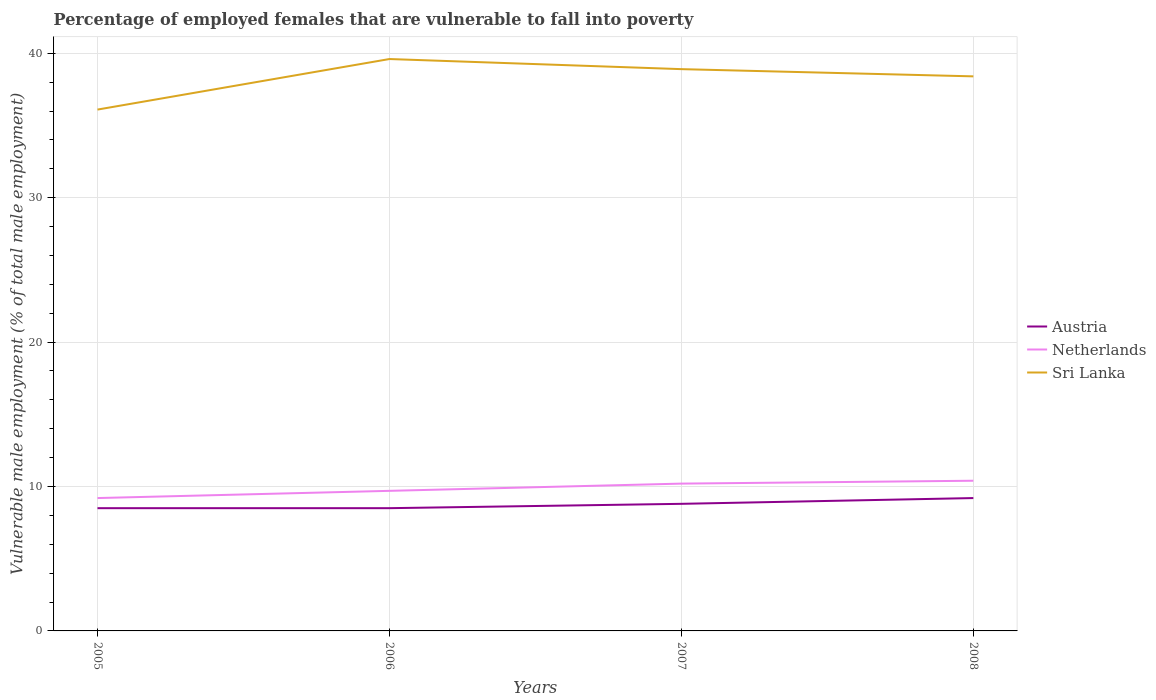How many different coloured lines are there?
Your response must be concise. 3. Does the line corresponding to Netherlands intersect with the line corresponding to Austria?
Give a very brief answer. No. In which year was the percentage of employed females who are vulnerable to fall into poverty in Netherlands maximum?
Offer a very short reply. 2005. What is the total percentage of employed females who are vulnerable to fall into poverty in Austria in the graph?
Your answer should be compact. -0.4. What is the difference between the highest and the second highest percentage of employed females who are vulnerable to fall into poverty in Netherlands?
Your answer should be very brief. 1.2. What is the difference between the highest and the lowest percentage of employed females who are vulnerable to fall into poverty in Austria?
Offer a terse response. 2. Is the percentage of employed females who are vulnerable to fall into poverty in Sri Lanka strictly greater than the percentage of employed females who are vulnerable to fall into poverty in Austria over the years?
Your answer should be compact. No. How many lines are there?
Provide a succinct answer. 3. How many years are there in the graph?
Your answer should be very brief. 4. Where does the legend appear in the graph?
Your answer should be very brief. Center right. How many legend labels are there?
Your response must be concise. 3. How are the legend labels stacked?
Your answer should be very brief. Vertical. What is the title of the graph?
Provide a short and direct response. Percentage of employed females that are vulnerable to fall into poverty. What is the label or title of the Y-axis?
Make the answer very short. Vulnerable male employment (% of total male employment). What is the Vulnerable male employment (% of total male employment) in Austria in 2005?
Ensure brevity in your answer.  8.5. What is the Vulnerable male employment (% of total male employment) of Netherlands in 2005?
Offer a very short reply. 9.2. What is the Vulnerable male employment (% of total male employment) in Sri Lanka in 2005?
Provide a succinct answer. 36.1. What is the Vulnerable male employment (% of total male employment) of Netherlands in 2006?
Keep it short and to the point. 9.7. What is the Vulnerable male employment (% of total male employment) in Sri Lanka in 2006?
Provide a succinct answer. 39.6. What is the Vulnerable male employment (% of total male employment) in Austria in 2007?
Provide a short and direct response. 8.8. What is the Vulnerable male employment (% of total male employment) in Netherlands in 2007?
Your answer should be very brief. 10.2. What is the Vulnerable male employment (% of total male employment) in Sri Lanka in 2007?
Keep it short and to the point. 38.9. What is the Vulnerable male employment (% of total male employment) of Austria in 2008?
Ensure brevity in your answer.  9.2. What is the Vulnerable male employment (% of total male employment) in Netherlands in 2008?
Your answer should be compact. 10.4. What is the Vulnerable male employment (% of total male employment) of Sri Lanka in 2008?
Give a very brief answer. 38.4. Across all years, what is the maximum Vulnerable male employment (% of total male employment) of Austria?
Offer a very short reply. 9.2. Across all years, what is the maximum Vulnerable male employment (% of total male employment) in Netherlands?
Ensure brevity in your answer.  10.4. Across all years, what is the maximum Vulnerable male employment (% of total male employment) of Sri Lanka?
Keep it short and to the point. 39.6. Across all years, what is the minimum Vulnerable male employment (% of total male employment) of Austria?
Your answer should be very brief. 8.5. Across all years, what is the minimum Vulnerable male employment (% of total male employment) in Netherlands?
Keep it short and to the point. 9.2. Across all years, what is the minimum Vulnerable male employment (% of total male employment) in Sri Lanka?
Provide a succinct answer. 36.1. What is the total Vulnerable male employment (% of total male employment) in Austria in the graph?
Offer a very short reply. 35. What is the total Vulnerable male employment (% of total male employment) in Netherlands in the graph?
Provide a succinct answer. 39.5. What is the total Vulnerable male employment (% of total male employment) in Sri Lanka in the graph?
Ensure brevity in your answer.  153. What is the difference between the Vulnerable male employment (% of total male employment) of Austria in 2005 and that in 2006?
Provide a short and direct response. 0. What is the difference between the Vulnerable male employment (% of total male employment) in Netherlands in 2005 and that in 2007?
Keep it short and to the point. -1. What is the difference between the Vulnerable male employment (% of total male employment) of Austria in 2006 and that in 2007?
Offer a very short reply. -0.3. What is the difference between the Vulnerable male employment (% of total male employment) in Austria in 2006 and that in 2008?
Your answer should be compact. -0.7. What is the difference between the Vulnerable male employment (% of total male employment) in Netherlands in 2006 and that in 2008?
Provide a succinct answer. -0.7. What is the difference between the Vulnerable male employment (% of total male employment) in Sri Lanka in 2006 and that in 2008?
Offer a very short reply. 1.2. What is the difference between the Vulnerable male employment (% of total male employment) of Netherlands in 2007 and that in 2008?
Provide a succinct answer. -0.2. What is the difference between the Vulnerable male employment (% of total male employment) of Austria in 2005 and the Vulnerable male employment (% of total male employment) of Netherlands in 2006?
Your response must be concise. -1.2. What is the difference between the Vulnerable male employment (% of total male employment) of Austria in 2005 and the Vulnerable male employment (% of total male employment) of Sri Lanka in 2006?
Provide a short and direct response. -31.1. What is the difference between the Vulnerable male employment (% of total male employment) in Netherlands in 2005 and the Vulnerable male employment (% of total male employment) in Sri Lanka in 2006?
Your answer should be very brief. -30.4. What is the difference between the Vulnerable male employment (% of total male employment) in Austria in 2005 and the Vulnerable male employment (% of total male employment) in Sri Lanka in 2007?
Make the answer very short. -30.4. What is the difference between the Vulnerable male employment (% of total male employment) of Netherlands in 2005 and the Vulnerable male employment (% of total male employment) of Sri Lanka in 2007?
Your response must be concise. -29.7. What is the difference between the Vulnerable male employment (% of total male employment) of Austria in 2005 and the Vulnerable male employment (% of total male employment) of Netherlands in 2008?
Offer a terse response. -1.9. What is the difference between the Vulnerable male employment (% of total male employment) of Austria in 2005 and the Vulnerable male employment (% of total male employment) of Sri Lanka in 2008?
Offer a very short reply. -29.9. What is the difference between the Vulnerable male employment (% of total male employment) of Netherlands in 2005 and the Vulnerable male employment (% of total male employment) of Sri Lanka in 2008?
Ensure brevity in your answer.  -29.2. What is the difference between the Vulnerable male employment (% of total male employment) in Austria in 2006 and the Vulnerable male employment (% of total male employment) in Sri Lanka in 2007?
Keep it short and to the point. -30.4. What is the difference between the Vulnerable male employment (% of total male employment) of Netherlands in 2006 and the Vulnerable male employment (% of total male employment) of Sri Lanka in 2007?
Offer a very short reply. -29.2. What is the difference between the Vulnerable male employment (% of total male employment) of Austria in 2006 and the Vulnerable male employment (% of total male employment) of Sri Lanka in 2008?
Your answer should be compact. -29.9. What is the difference between the Vulnerable male employment (% of total male employment) in Netherlands in 2006 and the Vulnerable male employment (% of total male employment) in Sri Lanka in 2008?
Offer a very short reply. -28.7. What is the difference between the Vulnerable male employment (% of total male employment) of Austria in 2007 and the Vulnerable male employment (% of total male employment) of Netherlands in 2008?
Offer a terse response. -1.6. What is the difference between the Vulnerable male employment (% of total male employment) in Austria in 2007 and the Vulnerable male employment (% of total male employment) in Sri Lanka in 2008?
Offer a very short reply. -29.6. What is the difference between the Vulnerable male employment (% of total male employment) in Netherlands in 2007 and the Vulnerable male employment (% of total male employment) in Sri Lanka in 2008?
Keep it short and to the point. -28.2. What is the average Vulnerable male employment (% of total male employment) of Austria per year?
Give a very brief answer. 8.75. What is the average Vulnerable male employment (% of total male employment) in Netherlands per year?
Ensure brevity in your answer.  9.88. What is the average Vulnerable male employment (% of total male employment) of Sri Lanka per year?
Offer a terse response. 38.25. In the year 2005, what is the difference between the Vulnerable male employment (% of total male employment) in Austria and Vulnerable male employment (% of total male employment) in Sri Lanka?
Provide a short and direct response. -27.6. In the year 2005, what is the difference between the Vulnerable male employment (% of total male employment) of Netherlands and Vulnerable male employment (% of total male employment) of Sri Lanka?
Provide a short and direct response. -26.9. In the year 2006, what is the difference between the Vulnerable male employment (% of total male employment) in Austria and Vulnerable male employment (% of total male employment) in Netherlands?
Offer a terse response. -1.2. In the year 2006, what is the difference between the Vulnerable male employment (% of total male employment) of Austria and Vulnerable male employment (% of total male employment) of Sri Lanka?
Give a very brief answer. -31.1. In the year 2006, what is the difference between the Vulnerable male employment (% of total male employment) in Netherlands and Vulnerable male employment (% of total male employment) in Sri Lanka?
Provide a succinct answer. -29.9. In the year 2007, what is the difference between the Vulnerable male employment (% of total male employment) in Austria and Vulnerable male employment (% of total male employment) in Sri Lanka?
Your answer should be very brief. -30.1. In the year 2007, what is the difference between the Vulnerable male employment (% of total male employment) in Netherlands and Vulnerable male employment (% of total male employment) in Sri Lanka?
Your answer should be very brief. -28.7. In the year 2008, what is the difference between the Vulnerable male employment (% of total male employment) in Austria and Vulnerable male employment (% of total male employment) in Netherlands?
Your response must be concise. -1.2. In the year 2008, what is the difference between the Vulnerable male employment (% of total male employment) of Austria and Vulnerable male employment (% of total male employment) of Sri Lanka?
Your answer should be very brief. -29.2. What is the ratio of the Vulnerable male employment (% of total male employment) of Netherlands in 2005 to that in 2006?
Make the answer very short. 0.95. What is the ratio of the Vulnerable male employment (% of total male employment) of Sri Lanka in 2005 to that in 2006?
Offer a very short reply. 0.91. What is the ratio of the Vulnerable male employment (% of total male employment) in Austria in 2005 to that in 2007?
Your response must be concise. 0.97. What is the ratio of the Vulnerable male employment (% of total male employment) of Netherlands in 2005 to that in 2007?
Give a very brief answer. 0.9. What is the ratio of the Vulnerable male employment (% of total male employment) of Sri Lanka in 2005 to that in 2007?
Keep it short and to the point. 0.93. What is the ratio of the Vulnerable male employment (% of total male employment) of Austria in 2005 to that in 2008?
Offer a terse response. 0.92. What is the ratio of the Vulnerable male employment (% of total male employment) in Netherlands in 2005 to that in 2008?
Make the answer very short. 0.88. What is the ratio of the Vulnerable male employment (% of total male employment) of Sri Lanka in 2005 to that in 2008?
Provide a succinct answer. 0.94. What is the ratio of the Vulnerable male employment (% of total male employment) in Austria in 2006 to that in 2007?
Provide a short and direct response. 0.97. What is the ratio of the Vulnerable male employment (% of total male employment) of Netherlands in 2006 to that in 2007?
Give a very brief answer. 0.95. What is the ratio of the Vulnerable male employment (% of total male employment) in Austria in 2006 to that in 2008?
Your answer should be very brief. 0.92. What is the ratio of the Vulnerable male employment (% of total male employment) in Netherlands in 2006 to that in 2008?
Ensure brevity in your answer.  0.93. What is the ratio of the Vulnerable male employment (% of total male employment) in Sri Lanka in 2006 to that in 2008?
Ensure brevity in your answer.  1.03. What is the ratio of the Vulnerable male employment (% of total male employment) of Austria in 2007 to that in 2008?
Keep it short and to the point. 0.96. What is the ratio of the Vulnerable male employment (% of total male employment) in Netherlands in 2007 to that in 2008?
Offer a very short reply. 0.98. What is the ratio of the Vulnerable male employment (% of total male employment) in Sri Lanka in 2007 to that in 2008?
Provide a succinct answer. 1.01. What is the difference between the highest and the second highest Vulnerable male employment (% of total male employment) in Austria?
Your answer should be very brief. 0.4. 